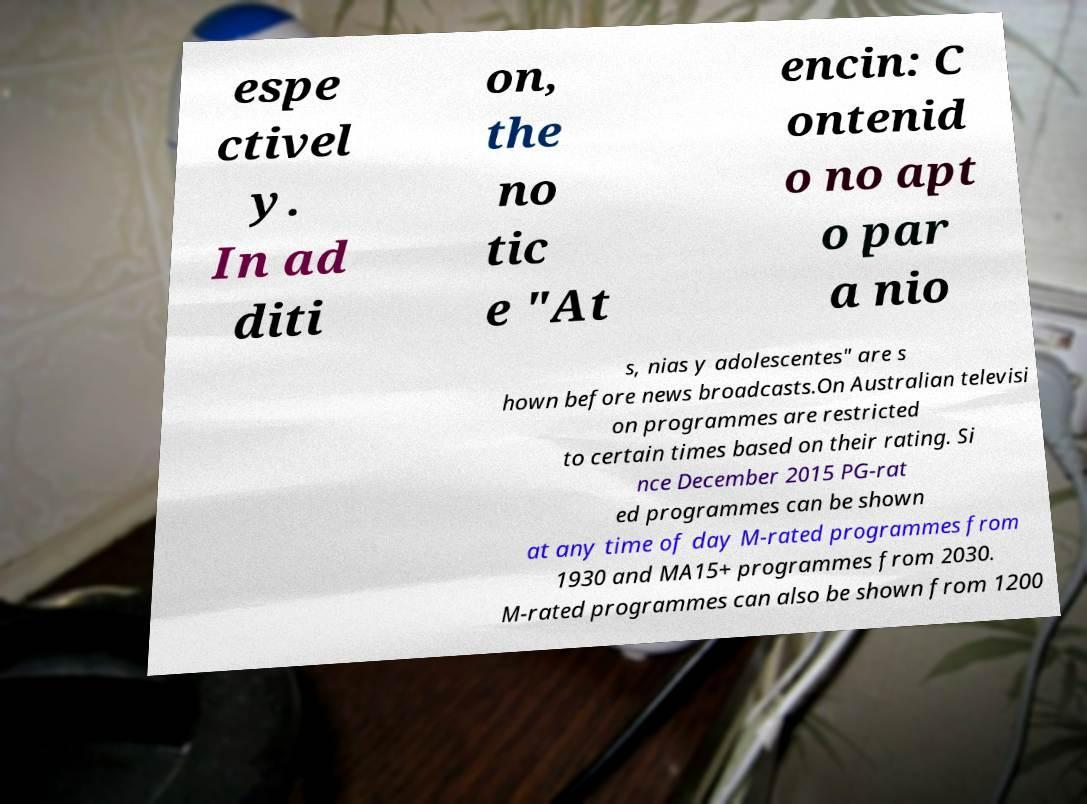What messages or text are displayed in this image? I need them in a readable, typed format. espe ctivel y. In ad diti on, the no tic e "At encin: C ontenid o no apt o par a nio s, nias y adolescentes" are s hown before news broadcasts.On Australian televisi on programmes are restricted to certain times based on their rating. Si nce December 2015 PG-rat ed programmes can be shown at any time of day M-rated programmes from 1930 and MA15+ programmes from 2030. M-rated programmes can also be shown from 1200 